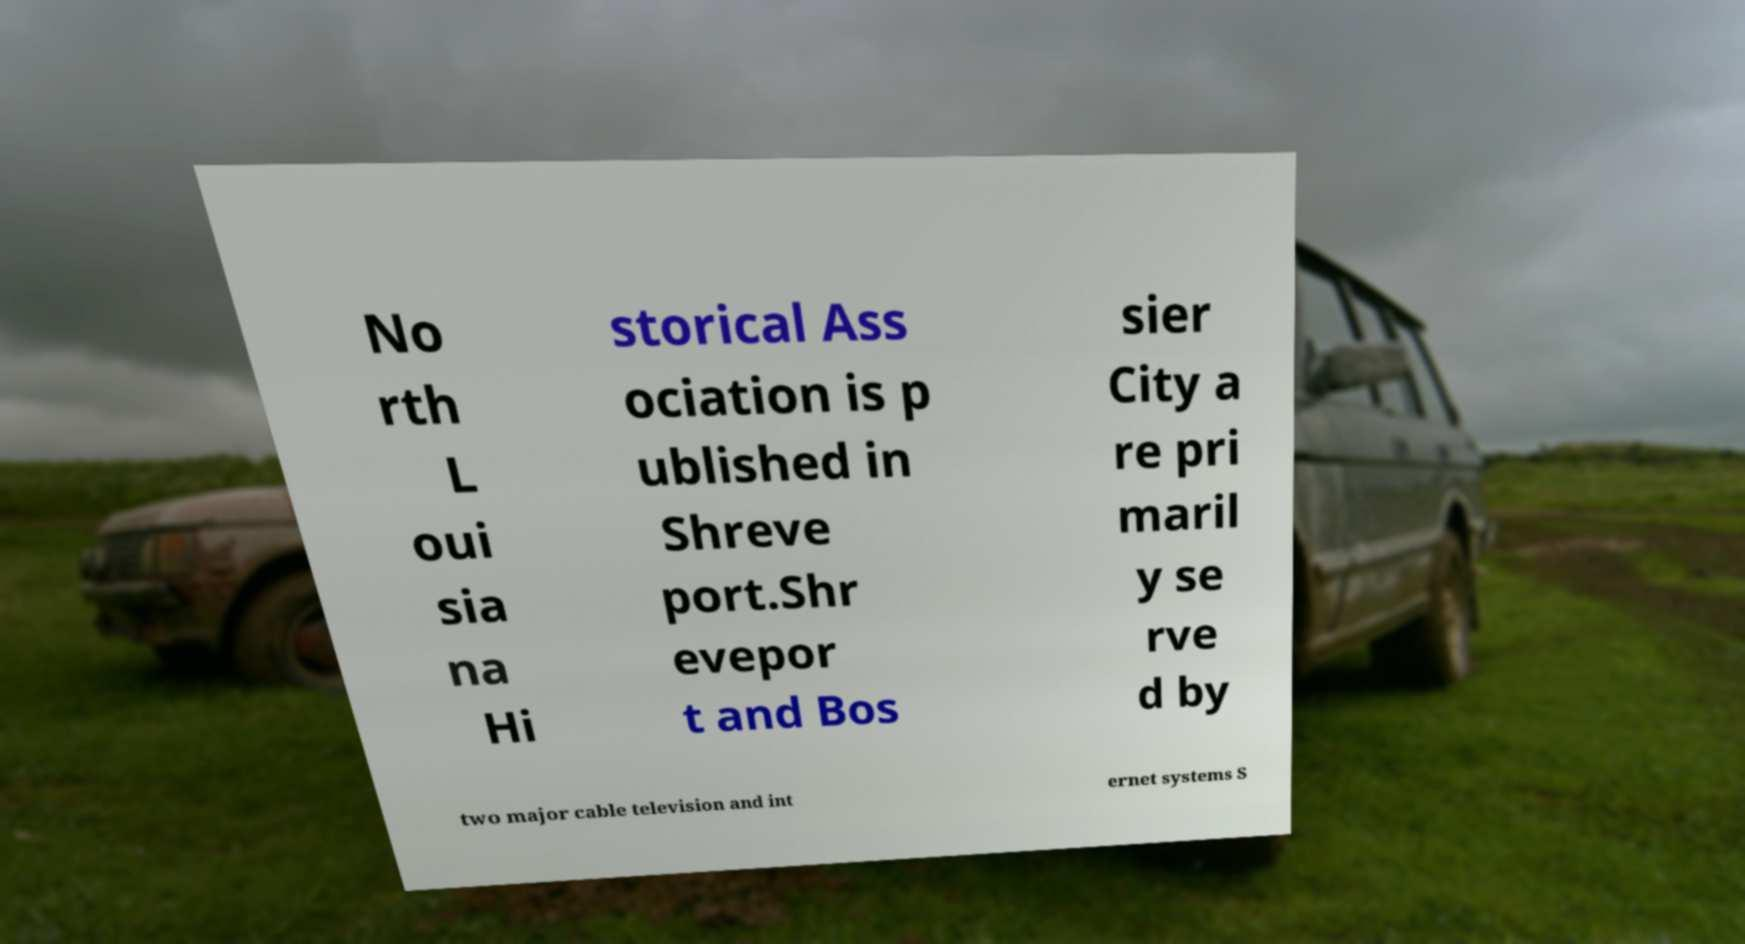Could you assist in decoding the text presented in this image and type it out clearly? No rth L oui sia na Hi storical Ass ociation is p ublished in Shreve port.Shr evepor t and Bos sier City a re pri maril y se rve d by two major cable television and int ernet systems S 